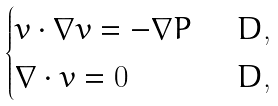<formula> <loc_0><loc_0><loc_500><loc_500>\begin{cases} v \cdot \nabla v = - \nabla P & \ \, D , \\ \nabla \cdot v = 0 \, \ \, \quad \, & \ \, D , \end{cases}</formula> 